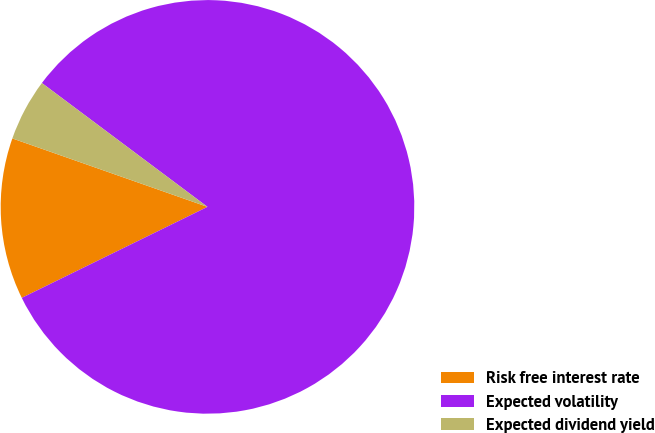Convert chart. <chart><loc_0><loc_0><loc_500><loc_500><pie_chart><fcel>Risk free interest rate<fcel>Expected volatility<fcel>Expected dividend yield<nl><fcel>12.62%<fcel>82.52%<fcel>4.85%<nl></chart> 